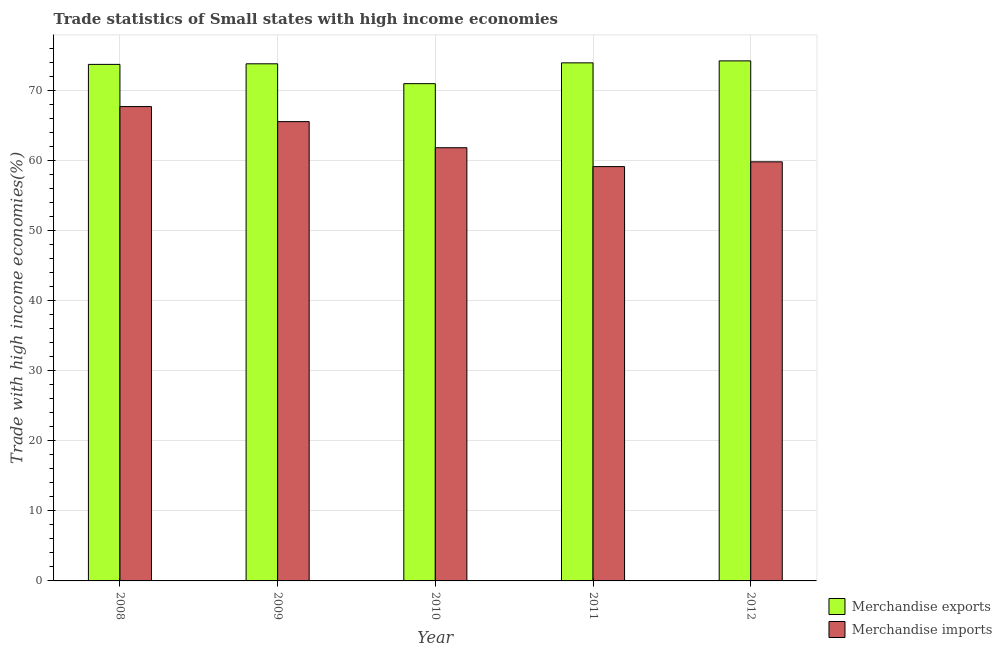How many different coloured bars are there?
Offer a terse response. 2. How many groups of bars are there?
Provide a short and direct response. 5. Are the number of bars per tick equal to the number of legend labels?
Ensure brevity in your answer.  Yes. Are the number of bars on each tick of the X-axis equal?
Your answer should be compact. Yes. How many bars are there on the 4th tick from the left?
Your answer should be compact. 2. How many bars are there on the 1st tick from the right?
Make the answer very short. 2. In how many cases, is the number of bars for a given year not equal to the number of legend labels?
Provide a succinct answer. 0. What is the merchandise imports in 2011?
Your answer should be very brief. 59.15. Across all years, what is the maximum merchandise imports?
Your response must be concise. 67.72. Across all years, what is the minimum merchandise exports?
Ensure brevity in your answer.  70.99. In which year was the merchandise exports minimum?
Ensure brevity in your answer.  2010. What is the total merchandise exports in the graph?
Your answer should be very brief. 366.76. What is the difference between the merchandise imports in 2009 and that in 2011?
Your response must be concise. 6.42. What is the difference between the merchandise exports in 2012 and the merchandise imports in 2008?
Your response must be concise. 0.5. What is the average merchandise exports per year?
Offer a terse response. 73.35. What is the ratio of the merchandise exports in 2009 to that in 2010?
Provide a succinct answer. 1.04. Is the merchandise exports in 2008 less than that in 2009?
Your answer should be compact. Yes. Is the difference between the merchandise imports in 2009 and 2010 greater than the difference between the merchandise exports in 2009 and 2010?
Offer a very short reply. No. What is the difference between the highest and the second highest merchandise imports?
Your answer should be compact. 2.15. What is the difference between the highest and the lowest merchandise exports?
Provide a short and direct response. 3.25. What does the 1st bar from the right in 2012 represents?
Your answer should be very brief. Merchandise imports. How many bars are there?
Offer a terse response. 10. How many years are there in the graph?
Ensure brevity in your answer.  5. What is the difference between two consecutive major ticks on the Y-axis?
Your response must be concise. 10. Are the values on the major ticks of Y-axis written in scientific E-notation?
Provide a succinct answer. No. How are the legend labels stacked?
Ensure brevity in your answer.  Vertical. What is the title of the graph?
Keep it short and to the point. Trade statistics of Small states with high income economies. What is the label or title of the X-axis?
Give a very brief answer. Year. What is the label or title of the Y-axis?
Provide a short and direct response. Trade with high income economies(%). What is the Trade with high income economies(%) in Merchandise exports in 2008?
Offer a very short reply. 73.74. What is the Trade with high income economies(%) in Merchandise imports in 2008?
Provide a short and direct response. 67.72. What is the Trade with high income economies(%) of Merchandise exports in 2009?
Your answer should be compact. 73.82. What is the Trade with high income economies(%) in Merchandise imports in 2009?
Provide a short and direct response. 65.57. What is the Trade with high income economies(%) in Merchandise exports in 2010?
Keep it short and to the point. 70.99. What is the Trade with high income economies(%) in Merchandise imports in 2010?
Give a very brief answer. 61.84. What is the Trade with high income economies(%) of Merchandise exports in 2011?
Keep it short and to the point. 73.96. What is the Trade with high income economies(%) of Merchandise imports in 2011?
Provide a short and direct response. 59.15. What is the Trade with high income economies(%) of Merchandise exports in 2012?
Provide a short and direct response. 74.24. What is the Trade with high income economies(%) of Merchandise imports in 2012?
Your response must be concise. 59.83. Across all years, what is the maximum Trade with high income economies(%) in Merchandise exports?
Provide a succinct answer. 74.24. Across all years, what is the maximum Trade with high income economies(%) in Merchandise imports?
Offer a very short reply. 67.72. Across all years, what is the minimum Trade with high income economies(%) of Merchandise exports?
Ensure brevity in your answer.  70.99. Across all years, what is the minimum Trade with high income economies(%) of Merchandise imports?
Keep it short and to the point. 59.15. What is the total Trade with high income economies(%) of Merchandise exports in the graph?
Ensure brevity in your answer.  366.76. What is the total Trade with high income economies(%) of Merchandise imports in the graph?
Offer a terse response. 314.12. What is the difference between the Trade with high income economies(%) in Merchandise exports in 2008 and that in 2009?
Your answer should be compact. -0.08. What is the difference between the Trade with high income economies(%) of Merchandise imports in 2008 and that in 2009?
Your answer should be very brief. 2.15. What is the difference between the Trade with high income economies(%) in Merchandise exports in 2008 and that in 2010?
Keep it short and to the point. 2.75. What is the difference between the Trade with high income economies(%) in Merchandise imports in 2008 and that in 2010?
Ensure brevity in your answer.  5.87. What is the difference between the Trade with high income economies(%) in Merchandise exports in 2008 and that in 2011?
Ensure brevity in your answer.  -0.22. What is the difference between the Trade with high income economies(%) of Merchandise imports in 2008 and that in 2011?
Offer a very short reply. 8.57. What is the difference between the Trade with high income economies(%) in Merchandise exports in 2008 and that in 2012?
Your answer should be compact. -0.5. What is the difference between the Trade with high income economies(%) of Merchandise imports in 2008 and that in 2012?
Offer a very short reply. 7.89. What is the difference between the Trade with high income economies(%) of Merchandise exports in 2009 and that in 2010?
Your answer should be very brief. 2.84. What is the difference between the Trade with high income economies(%) in Merchandise imports in 2009 and that in 2010?
Keep it short and to the point. 3.73. What is the difference between the Trade with high income economies(%) in Merchandise exports in 2009 and that in 2011?
Provide a short and direct response. -0.14. What is the difference between the Trade with high income economies(%) in Merchandise imports in 2009 and that in 2011?
Your answer should be very brief. 6.42. What is the difference between the Trade with high income economies(%) in Merchandise exports in 2009 and that in 2012?
Make the answer very short. -0.42. What is the difference between the Trade with high income economies(%) in Merchandise imports in 2009 and that in 2012?
Keep it short and to the point. 5.74. What is the difference between the Trade with high income economies(%) of Merchandise exports in 2010 and that in 2011?
Offer a terse response. -2.97. What is the difference between the Trade with high income economies(%) in Merchandise imports in 2010 and that in 2011?
Ensure brevity in your answer.  2.69. What is the difference between the Trade with high income economies(%) in Merchandise exports in 2010 and that in 2012?
Your answer should be very brief. -3.25. What is the difference between the Trade with high income economies(%) in Merchandise imports in 2010 and that in 2012?
Your answer should be compact. 2.01. What is the difference between the Trade with high income economies(%) of Merchandise exports in 2011 and that in 2012?
Make the answer very short. -0.28. What is the difference between the Trade with high income economies(%) in Merchandise imports in 2011 and that in 2012?
Ensure brevity in your answer.  -0.68. What is the difference between the Trade with high income economies(%) of Merchandise exports in 2008 and the Trade with high income economies(%) of Merchandise imports in 2009?
Offer a terse response. 8.17. What is the difference between the Trade with high income economies(%) of Merchandise exports in 2008 and the Trade with high income economies(%) of Merchandise imports in 2010?
Keep it short and to the point. 11.9. What is the difference between the Trade with high income economies(%) of Merchandise exports in 2008 and the Trade with high income economies(%) of Merchandise imports in 2011?
Keep it short and to the point. 14.59. What is the difference between the Trade with high income economies(%) in Merchandise exports in 2008 and the Trade with high income economies(%) in Merchandise imports in 2012?
Your answer should be compact. 13.91. What is the difference between the Trade with high income economies(%) of Merchandise exports in 2009 and the Trade with high income economies(%) of Merchandise imports in 2010?
Your response must be concise. 11.98. What is the difference between the Trade with high income economies(%) in Merchandise exports in 2009 and the Trade with high income economies(%) in Merchandise imports in 2011?
Offer a very short reply. 14.68. What is the difference between the Trade with high income economies(%) of Merchandise exports in 2009 and the Trade with high income economies(%) of Merchandise imports in 2012?
Provide a short and direct response. 13.99. What is the difference between the Trade with high income economies(%) in Merchandise exports in 2010 and the Trade with high income economies(%) in Merchandise imports in 2011?
Provide a succinct answer. 11.84. What is the difference between the Trade with high income economies(%) of Merchandise exports in 2010 and the Trade with high income economies(%) of Merchandise imports in 2012?
Give a very brief answer. 11.16. What is the difference between the Trade with high income economies(%) in Merchandise exports in 2011 and the Trade with high income economies(%) in Merchandise imports in 2012?
Provide a succinct answer. 14.13. What is the average Trade with high income economies(%) in Merchandise exports per year?
Your response must be concise. 73.35. What is the average Trade with high income economies(%) of Merchandise imports per year?
Your answer should be compact. 62.82. In the year 2008, what is the difference between the Trade with high income economies(%) in Merchandise exports and Trade with high income economies(%) in Merchandise imports?
Give a very brief answer. 6.02. In the year 2009, what is the difference between the Trade with high income economies(%) in Merchandise exports and Trade with high income economies(%) in Merchandise imports?
Offer a very short reply. 8.25. In the year 2010, what is the difference between the Trade with high income economies(%) of Merchandise exports and Trade with high income economies(%) of Merchandise imports?
Keep it short and to the point. 9.14. In the year 2011, what is the difference between the Trade with high income economies(%) in Merchandise exports and Trade with high income economies(%) in Merchandise imports?
Your answer should be very brief. 14.81. In the year 2012, what is the difference between the Trade with high income economies(%) of Merchandise exports and Trade with high income economies(%) of Merchandise imports?
Make the answer very short. 14.41. What is the ratio of the Trade with high income economies(%) of Merchandise exports in 2008 to that in 2009?
Ensure brevity in your answer.  1. What is the ratio of the Trade with high income economies(%) in Merchandise imports in 2008 to that in 2009?
Ensure brevity in your answer.  1.03. What is the ratio of the Trade with high income economies(%) of Merchandise exports in 2008 to that in 2010?
Ensure brevity in your answer.  1.04. What is the ratio of the Trade with high income economies(%) in Merchandise imports in 2008 to that in 2010?
Provide a succinct answer. 1.09. What is the ratio of the Trade with high income economies(%) in Merchandise exports in 2008 to that in 2011?
Offer a terse response. 1. What is the ratio of the Trade with high income economies(%) in Merchandise imports in 2008 to that in 2011?
Give a very brief answer. 1.14. What is the ratio of the Trade with high income economies(%) of Merchandise exports in 2008 to that in 2012?
Provide a short and direct response. 0.99. What is the ratio of the Trade with high income economies(%) of Merchandise imports in 2008 to that in 2012?
Offer a very short reply. 1.13. What is the ratio of the Trade with high income economies(%) of Merchandise exports in 2009 to that in 2010?
Your answer should be very brief. 1.04. What is the ratio of the Trade with high income economies(%) of Merchandise imports in 2009 to that in 2010?
Your response must be concise. 1.06. What is the ratio of the Trade with high income economies(%) of Merchandise exports in 2009 to that in 2011?
Make the answer very short. 1. What is the ratio of the Trade with high income economies(%) in Merchandise imports in 2009 to that in 2011?
Offer a terse response. 1.11. What is the ratio of the Trade with high income economies(%) in Merchandise exports in 2009 to that in 2012?
Give a very brief answer. 0.99. What is the ratio of the Trade with high income economies(%) in Merchandise imports in 2009 to that in 2012?
Keep it short and to the point. 1.1. What is the ratio of the Trade with high income economies(%) in Merchandise exports in 2010 to that in 2011?
Provide a short and direct response. 0.96. What is the ratio of the Trade with high income economies(%) in Merchandise imports in 2010 to that in 2011?
Give a very brief answer. 1.05. What is the ratio of the Trade with high income economies(%) in Merchandise exports in 2010 to that in 2012?
Provide a short and direct response. 0.96. What is the ratio of the Trade with high income economies(%) of Merchandise imports in 2010 to that in 2012?
Give a very brief answer. 1.03. What is the ratio of the Trade with high income economies(%) in Merchandise exports in 2011 to that in 2012?
Give a very brief answer. 1. What is the difference between the highest and the second highest Trade with high income economies(%) of Merchandise exports?
Provide a succinct answer. 0.28. What is the difference between the highest and the second highest Trade with high income economies(%) of Merchandise imports?
Ensure brevity in your answer.  2.15. What is the difference between the highest and the lowest Trade with high income economies(%) of Merchandise exports?
Provide a short and direct response. 3.25. What is the difference between the highest and the lowest Trade with high income economies(%) of Merchandise imports?
Provide a short and direct response. 8.57. 